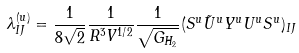<formula> <loc_0><loc_0><loc_500><loc_500>\lambda ^ { ( u ) } _ { I J } = \frac { 1 } { 8 \sqrt { 2 } } \frac { 1 } { R ^ { 3 } V ^ { 1 / 2 } } \frac { 1 } { \sqrt { G _ { H _ { 2 } } } } ( S ^ { u } { \tilde { U } ^ { u } } Y ^ { u } U ^ { u } S ^ { u } ) _ { I J }</formula> 